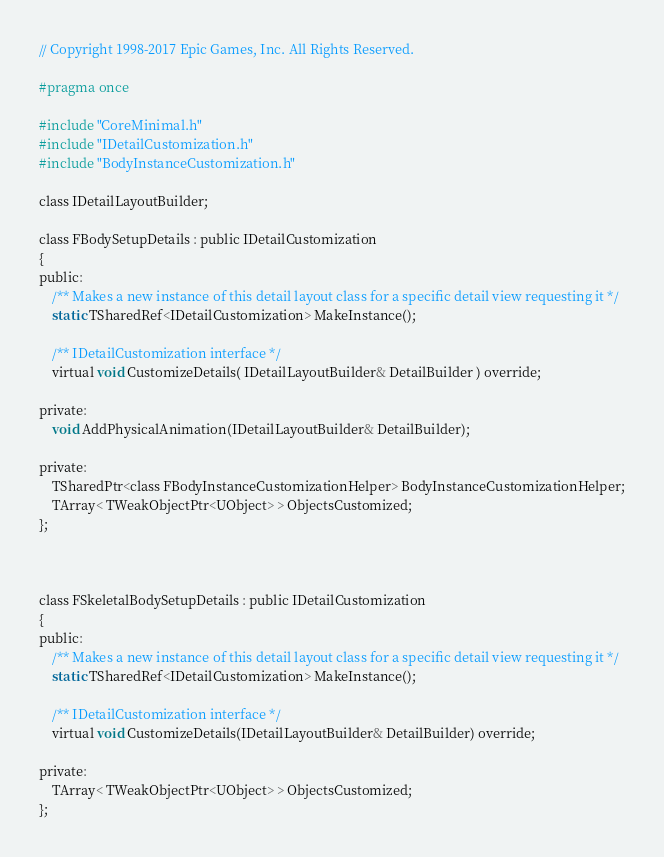Convert code to text. <code><loc_0><loc_0><loc_500><loc_500><_C_>// Copyright 1998-2017 Epic Games, Inc. All Rights Reserved.

#pragma once

#include "CoreMinimal.h"
#include "IDetailCustomization.h"
#include "BodyInstanceCustomization.h"

class IDetailLayoutBuilder;

class FBodySetupDetails : public IDetailCustomization
{
public:
	/** Makes a new instance of this detail layout class for a specific detail view requesting it */
	static TSharedRef<IDetailCustomization> MakeInstance();

	/** IDetailCustomization interface */
	virtual void CustomizeDetails( IDetailLayoutBuilder& DetailBuilder ) override;

private:
	void AddPhysicalAnimation(IDetailLayoutBuilder& DetailBuilder);

private:
	TSharedPtr<class FBodyInstanceCustomizationHelper> BodyInstanceCustomizationHelper;
	TArray< TWeakObjectPtr<UObject> > ObjectsCustomized;
};



class FSkeletalBodySetupDetails : public IDetailCustomization
{
public:
	/** Makes a new instance of this detail layout class for a specific detail view requesting it */
	static TSharedRef<IDetailCustomization> MakeInstance();

	/** IDetailCustomization interface */
	virtual void CustomizeDetails(IDetailLayoutBuilder& DetailBuilder) override;

private:
	TArray< TWeakObjectPtr<UObject> > ObjectsCustomized;
};

</code> 